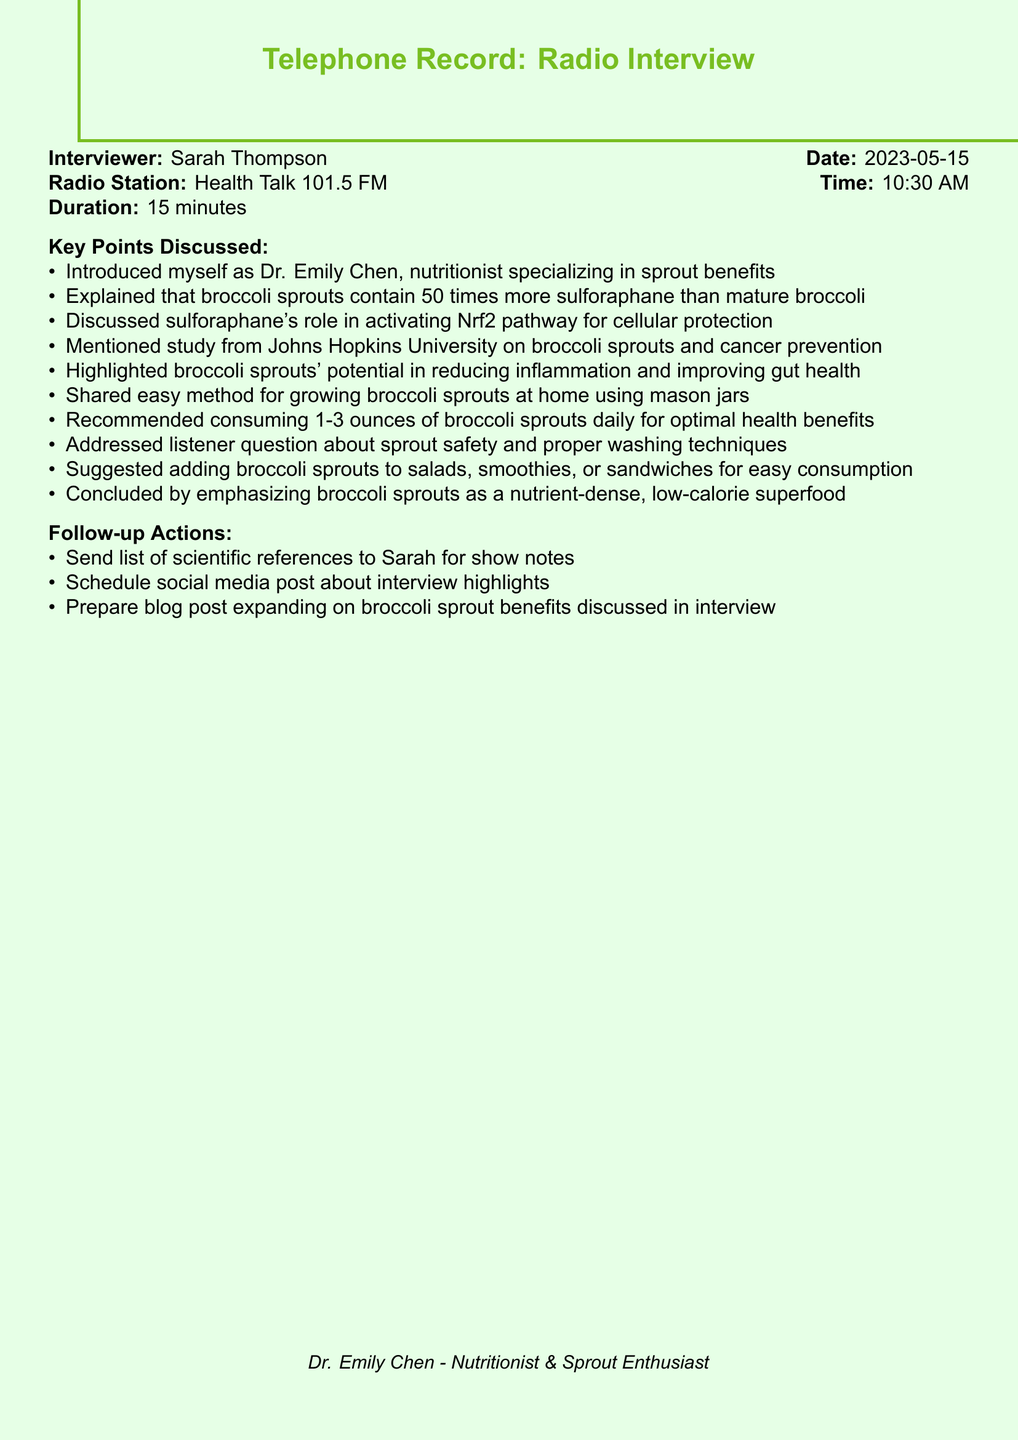What is the interviewer's name? The interviewer's name is mentioned at the beginning of the document.
Answer: Sarah Thompson On what date did the interview take place? The date is specified near the start of the document.
Answer: 2023-05-15 What is the duration of the interview? The duration is clearly stated in the document.
Answer: 15 minutes How much sulforaphane do broccoli sprouts contain compared to mature broccoli? The comparison is made in the document, highlighting the greater concentration.
Answer: 50 times more Which university conducted a study on broccoli sprouts and cancer prevention? The document refers to a specific institution that conducted the study.
Answer: Johns Hopkins University What daily amount of broccoli sprouts is recommended for optimal health benefits? The recommendation is provided in the key points discussed.
Answer: 1-3 ounces What are two benefits of broccoli sprouts mentioned? The document lists benefits of broccoli sprouts, requiring an overview for this question.
Answer: Reducing inflammation and improving gut health What action is planned regarding scientific references? A specific follow-up action is noted in the document regarding sending information.
Answer: Send list of scientific references Which radio station aired the interview? The radio station is mentioned in the introductory section of the document.
Answer: Health Talk 101.5 FM What is the last statement made by Dr. Emily Chen? The conclusion made at the end of the key points can be referenced for this information.
Answer: Nutrient-dense, low-calorie superfood 